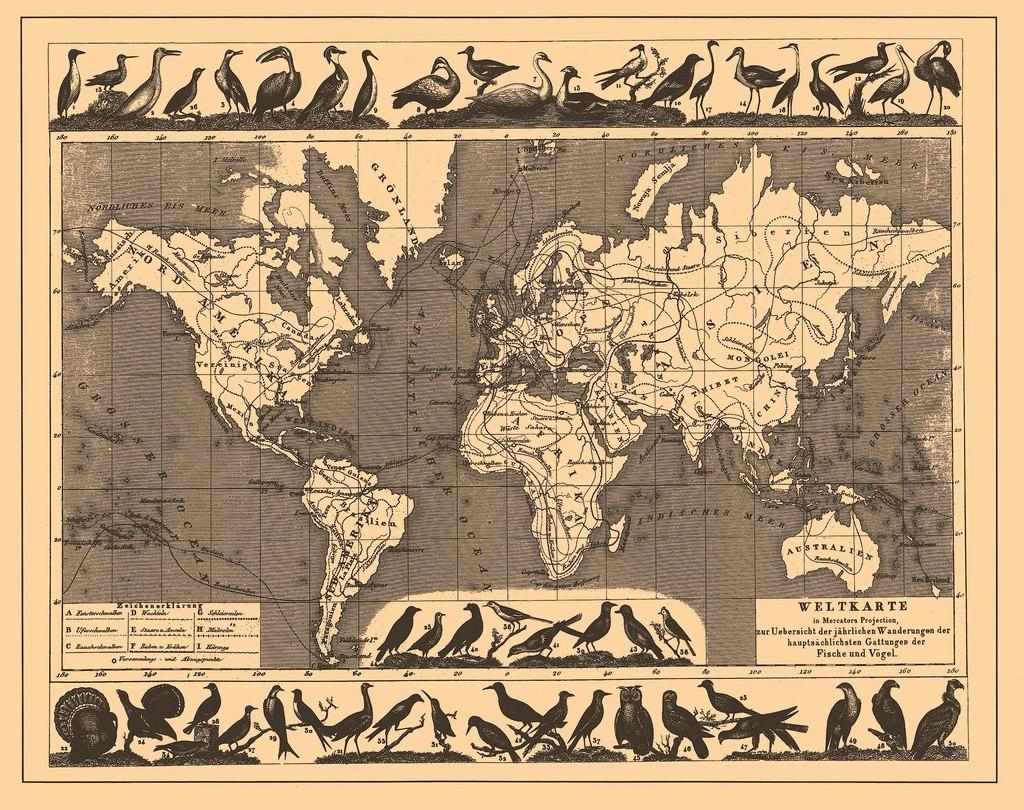<image>
Present a compact description of the photo's key features. A map of the world spells Amerika with a K. 